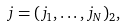<formula> <loc_0><loc_0><loc_500><loc_500>j = ( j _ { 1 } , \dots , j _ { N } ) _ { 2 } ,</formula> 